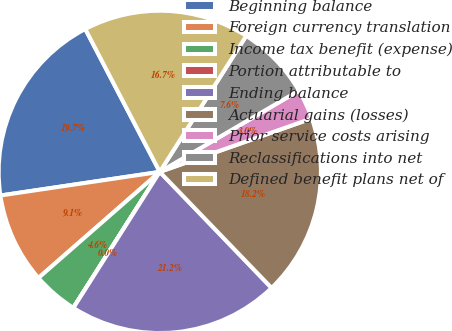Convert chart to OTSL. <chart><loc_0><loc_0><loc_500><loc_500><pie_chart><fcel>Beginning balance<fcel>Foreign currency translation<fcel>Income tax benefit (expense)<fcel>Portion attributable to<fcel>Ending balance<fcel>Actuarial gains (losses)<fcel>Prior service costs arising<fcel>Reclassifications into net<fcel>Defined benefit plans net of<nl><fcel>19.69%<fcel>9.09%<fcel>4.55%<fcel>0.01%<fcel>21.21%<fcel>18.18%<fcel>3.03%<fcel>7.58%<fcel>16.66%<nl></chart> 